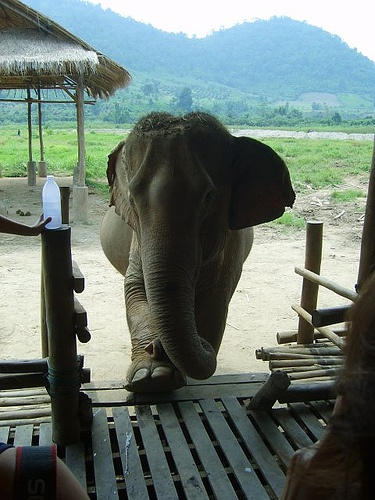Describe the objects in this image and their specific colors. I can see elephant in gray, black, and darkgreen tones and bottle in gray, lightblue, and lavender tones in this image. 